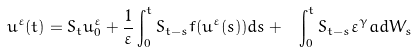Convert formula to latex. <formula><loc_0><loc_0><loc_500><loc_500>u ^ { \varepsilon } ( t ) = S _ { t } u _ { 0 } ^ { \varepsilon } + \frac { 1 } { \varepsilon } \int _ { 0 } ^ { t } S _ { t - s } f ( u ^ { \varepsilon } ( s ) ) d s + \ \int _ { 0 } ^ { t } S _ { t - s } \varepsilon ^ { \gamma } a d W _ { s }</formula> 